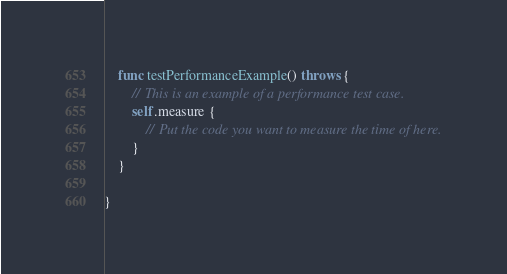Convert code to text. <code><loc_0><loc_0><loc_500><loc_500><_Swift_>
    func testPerformanceExample() throws {
        // This is an example of a performance test case.
        self.measure {
            // Put the code you want to measure the time of here.
        }
    }

}
</code> 